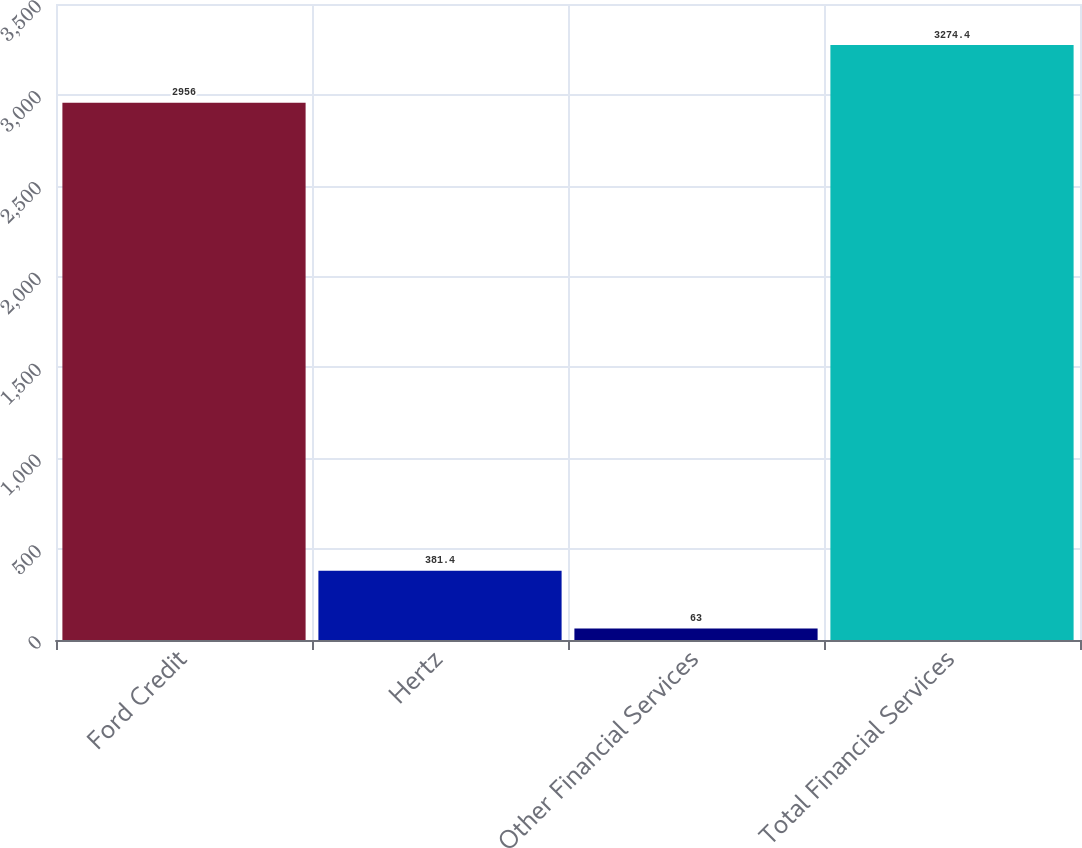Convert chart. <chart><loc_0><loc_0><loc_500><loc_500><bar_chart><fcel>Ford Credit<fcel>Hertz<fcel>Other Financial Services<fcel>Total Financial Services<nl><fcel>2956<fcel>381.4<fcel>63<fcel>3274.4<nl></chart> 